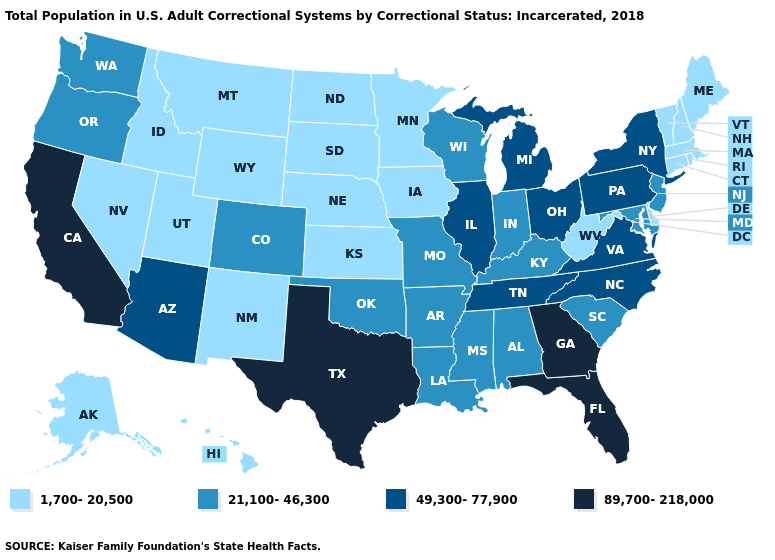Which states have the lowest value in the USA?
Give a very brief answer. Alaska, Connecticut, Delaware, Hawaii, Idaho, Iowa, Kansas, Maine, Massachusetts, Minnesota, Montana, Nebraska, Nevada, New Hampshire, New Mexico, North Dakota, Rhode Island, South Dakota, Utah, Vermont, West Virginia, Wyoming. What is the value of Texas?
Concise answer only. 89,700-218,000. Which states have the lowest value in the USA?
Write a very short answer. Alaska, Connecticut, Delaware, Hawaii, Idaho, Iowa, Kansas, Maine, Massachusetts, Minnesota, Montana, Nebraska, Nevada, New Hampshire, New Mexico, North Dakota, Rhode Island, South Dakota, Utah, Vermont, West Virginia, Wyoming. What is the lowest value in the South?
Quick response, please. 1,700-20,500. Does the first symbol in the legend represent the smallest category?
Keep it brief. Yes. Does North Dakota have the highest value in the MidWest?
Answer briefly. No. Name the states that have a value in the range 89,700-218,000?
Concise answer only. California, Florida, Georgia, Texas. Name the states that have a value in the range 89,700-218,000?
Keep it brief. California, Florida, Georgia, Texas. Does Wisconsin have the lowest value in the USA?
Be succinct. No. Among the states that border Oregon , does Idaho have the lowest value?
Write a very short answer. Yes. What is the highest value in the USA?
Answer briefly. 89,700-218,000. Does the first symbol in the legend represent the smallest category?
Answer briefly. Yes. What is the value of New Mexico?
Keep it brief. 1,700-20,500. Name the states that have a value in the range 49,300-77,900?
Quick response, please. Arizona, Illinois, Michigan, New York, North Carolina, Ohio, Pennsylvania, Tennessee, Virginia. What is the value of South Carolina?
Short answer required. 21,100-46,300. 